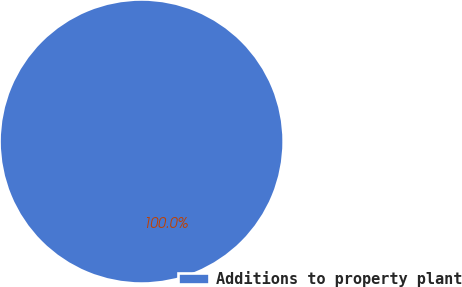Convert chart to OTSL. <chart><loc_0><loc_0><loc_500><loc_500><pie_chart><fcel>Additions to property plant<nl><fcel>100.0%<nl></chart> 